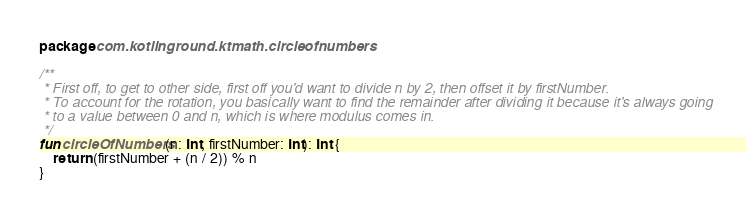Convert code to text. <code><loc_0><loc_0><loc_500><loc_500><_Kotlin_>package com.kotlinground.ktmath.circleofnumbers

/**
 * First off, to get to other side, first off you'd want to divide n by 2, then offset it by firstNumber.
 * To account for the rotation, you basically want to find the remainder after dividing it because it's always going
 * to a value between 0 and n, which is where modulus comes in.
 */
fun circleOfNumbers(n: Int, firstNumber: Int): Int {
    return (firstNumber + (n / 2)) % n
}
</code> 